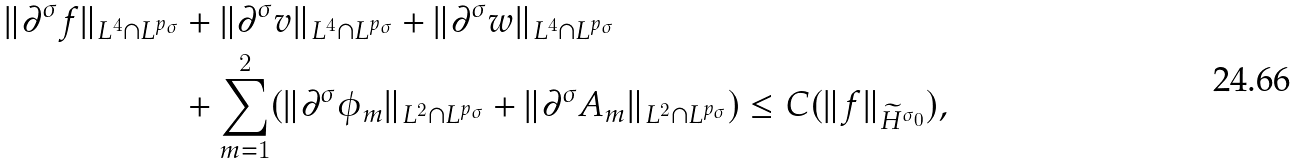<formula> <loc_0><loc_0><loc_500><loc_500>\| \partial ^ { \sigma } f \| _ { L ^ { 4 } \cap L ^ { p _ { \sigma } } } & + \| \partial ^ { \sigma } v \| _ { L ^ { 4 } \cap L ^ { p _ { \sigma } } } + \| \partial ^ { \sigma } w \| _ { L ^ { 4 } \cap L ^ { p _ { \sigma } } } \\ & + \sum _ { m = 1 } ^ { 2 } ( \| \partial ^ { \sigma } \phi _ { m } \| _ { L ^ { 2 } \cap L ^ { p _ { \sigma } } } + \| \partial ^ { \sigma } A _ { m } \| _ { L ^ { 2 } \cap L ^ { p _ { \sigma } } } ) \leq C ( \| f \| _ { \widetilde { H } ^ { \sigma _ { 0 } } } ) ,</formula> 